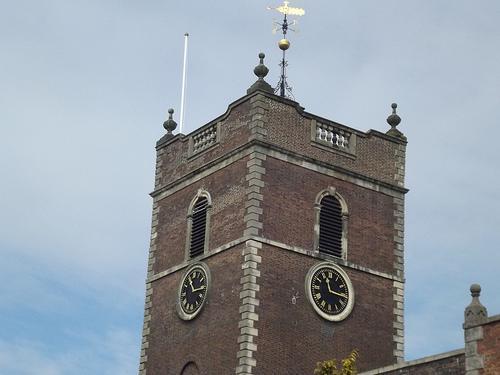How many clocks are there?
Give a very brief answer. 2. 